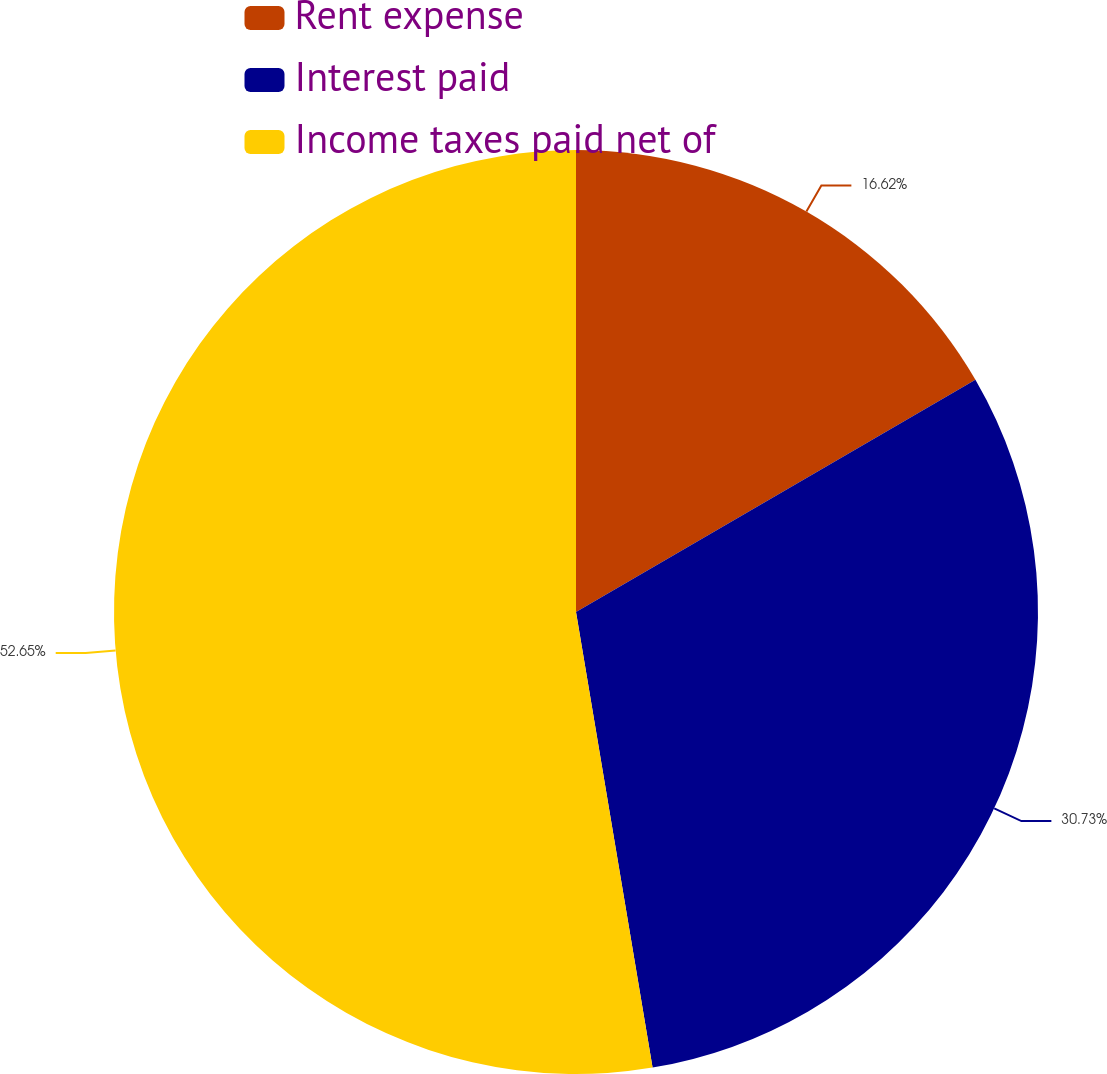<chart> <loc_0><loc_0><loc_500><loc_500><pie_chart><fcel>Rent expense<fcel>Interest paid<fcel>Income taxes paid net of<nl><fcel>16.62%<fcel>30.73%<fcel>52.65%<nl></chart> 